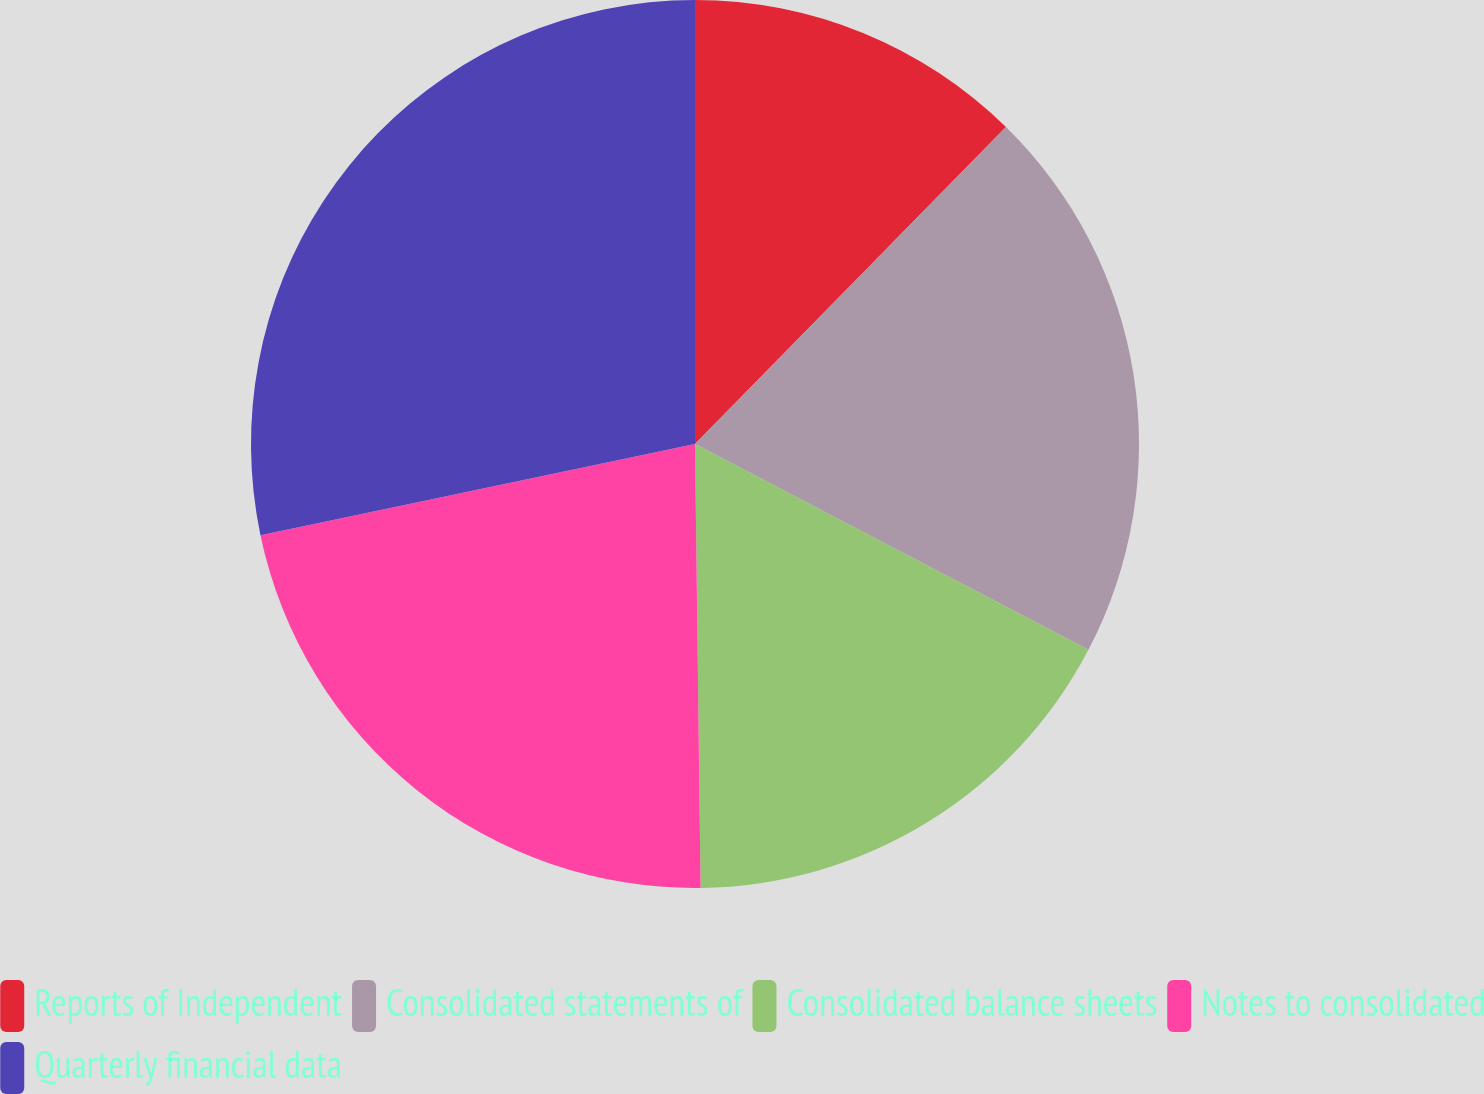<chart> <loc_0><loc_0><loc_500><loc_500><pie_chart><fcel>Reports of Independent<fcel>Consolidated statements of<fcel>Consolidated balance sheets<fcel>Notes to consolidated<fcel>Quarterly financial data<nl><fcel>12.35%<fcel>20.32%<fcel>17.13%<fcel>21.91%<fcel>28.29%<nl></chart> 